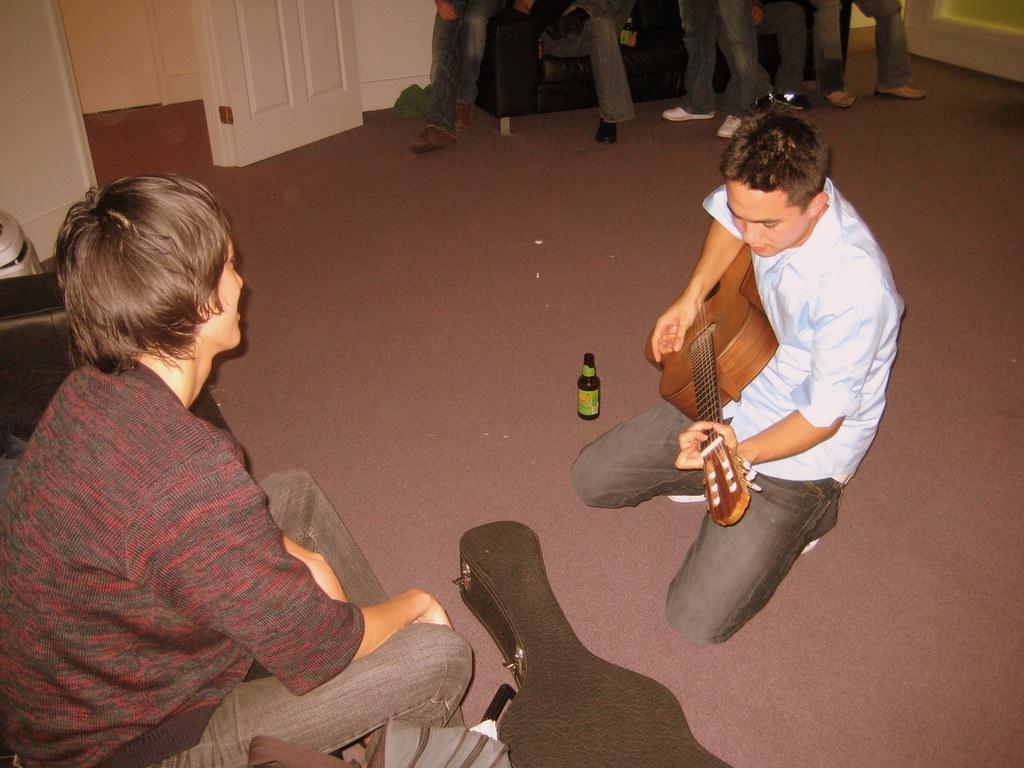How would you summarize this image in a sentence or two? In this image i can see a person kneeling on the ground holding a guitar. To the left corner i can see another person sitting on a couch. In the background i can see legs of few people, a couch, door and a wall. 